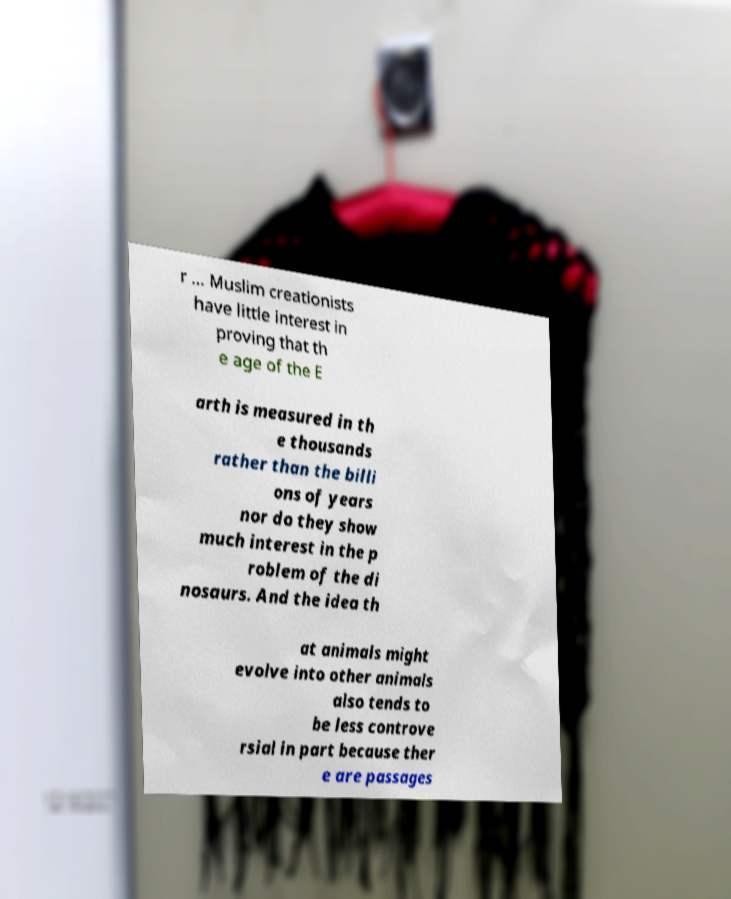Please identify and transcribe the text found in this image. r ... Muslim creationists have little interest in proving that th e age of the E arth is measured in th e thousands rather than the billi ons of years nor do they show much interest in the p roblem of the di nosaurs. And the idea th at animals might evolve into other animals also tends to be less controve rsial in part because ther e are passages 